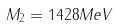<formula> <loc_0><loc_0><loc_500><loc_500>M _ { 2 } = 1 4 2 8 M e V</formula> 